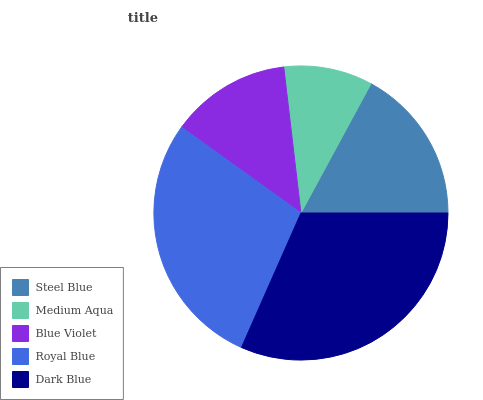Is Medium Aqua the minimum?
Answer yes or no. Yes. Is Dark Blue the maximum?
Answer yes or no. Yes. Is Blue Violet the minimum?
Answer yes or no. No. Is Blue Violet the maximum?
Answer yes or no. No. Is Blue Violet greater than Medium Aqua?
Answer yes or no. Yes. Is Medium Aqua less than Blue Violet?
Answer yes or no. Yes. Is Medium Aqua greater than Blue Violet?
Answer yes or no. No. Is Blue Violet less than Medium Aqua?
Answer yes or no. No. Is Steel Blue the high median?
Answer yes or no. Yes. Is Steel Blue the low median?
Answer yes or no. Yes. Is Blue Violet the high median?
Answer yes or no. No. Is Medium Aqua the low median?
Answer yes or no. No. 